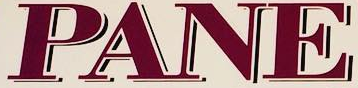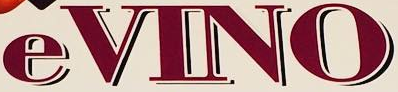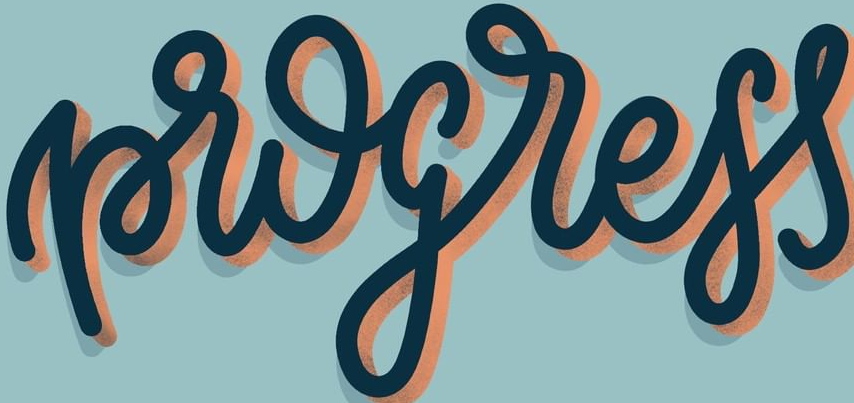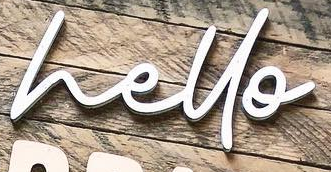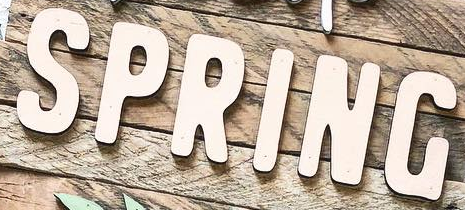Read the text from these images in sequence, separated by a semicolon. PANE; eVINO; progress; hello; SPRING 